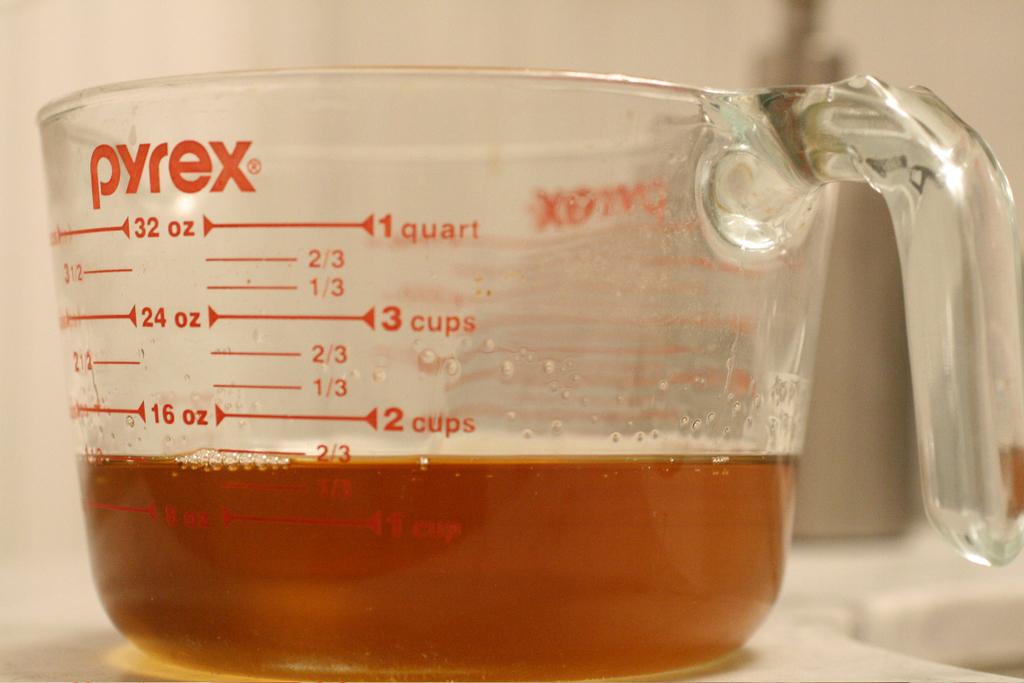What's the brand name of this measuring cup?
Provide a succinct answer. Pyrex. What is the ounces below the letters y and r?
Your answer should be compact. 32. 